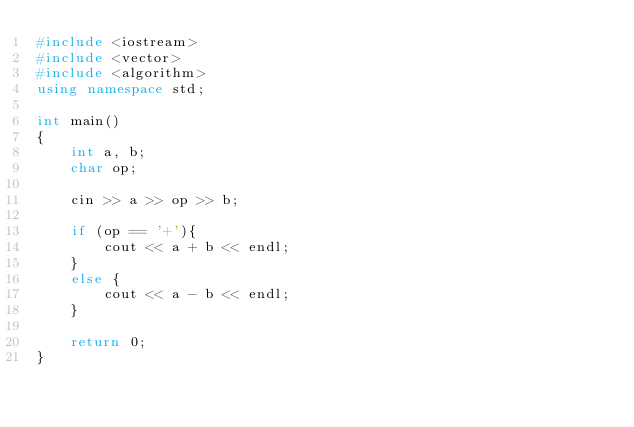Convert code to text. <code><loc_0><loc_0><loc_500><loc_500><_C++_>#include <iostream>
#include <vector>
#include <algorithm>
using namespace std;

int main()
{
    int a, b;
    char op;

    cin >> a >> op >> b;

    if (op == '+'){
        cout << a + b << endl;
    }
    else {
        cout << a - b << endl;
    }

    return 0;
}</code> 